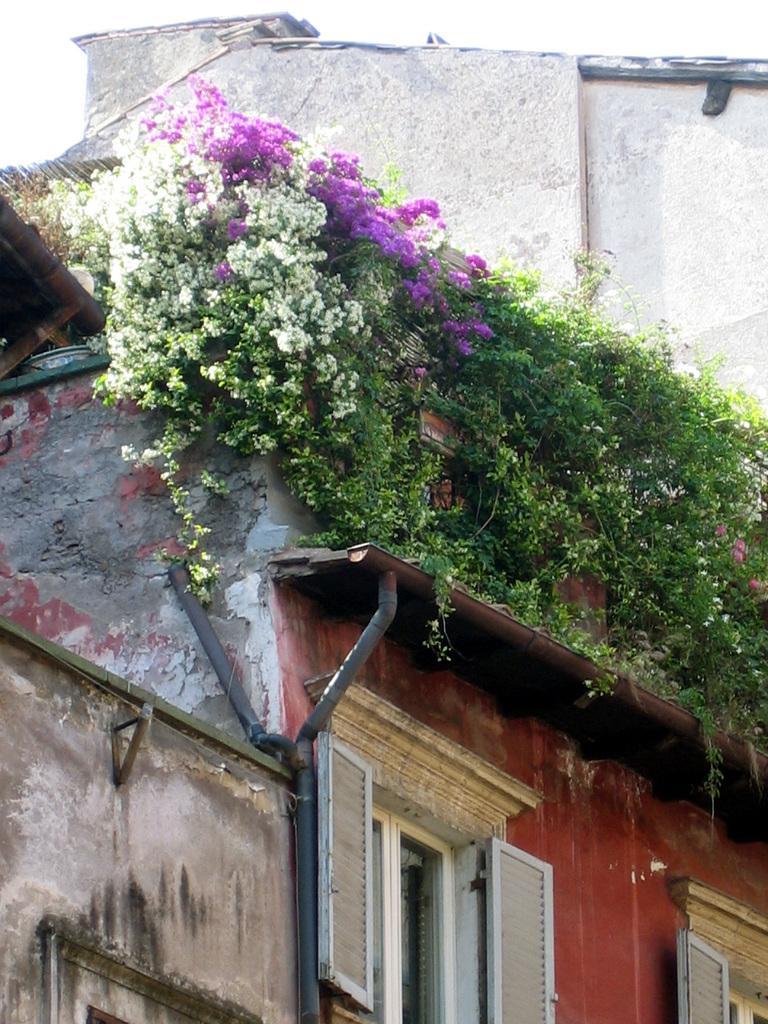Please provide a concise description of this image. In this image we can see a building, there are some windows, plants, flowers and a pole, also we can see the wall and the sky. 